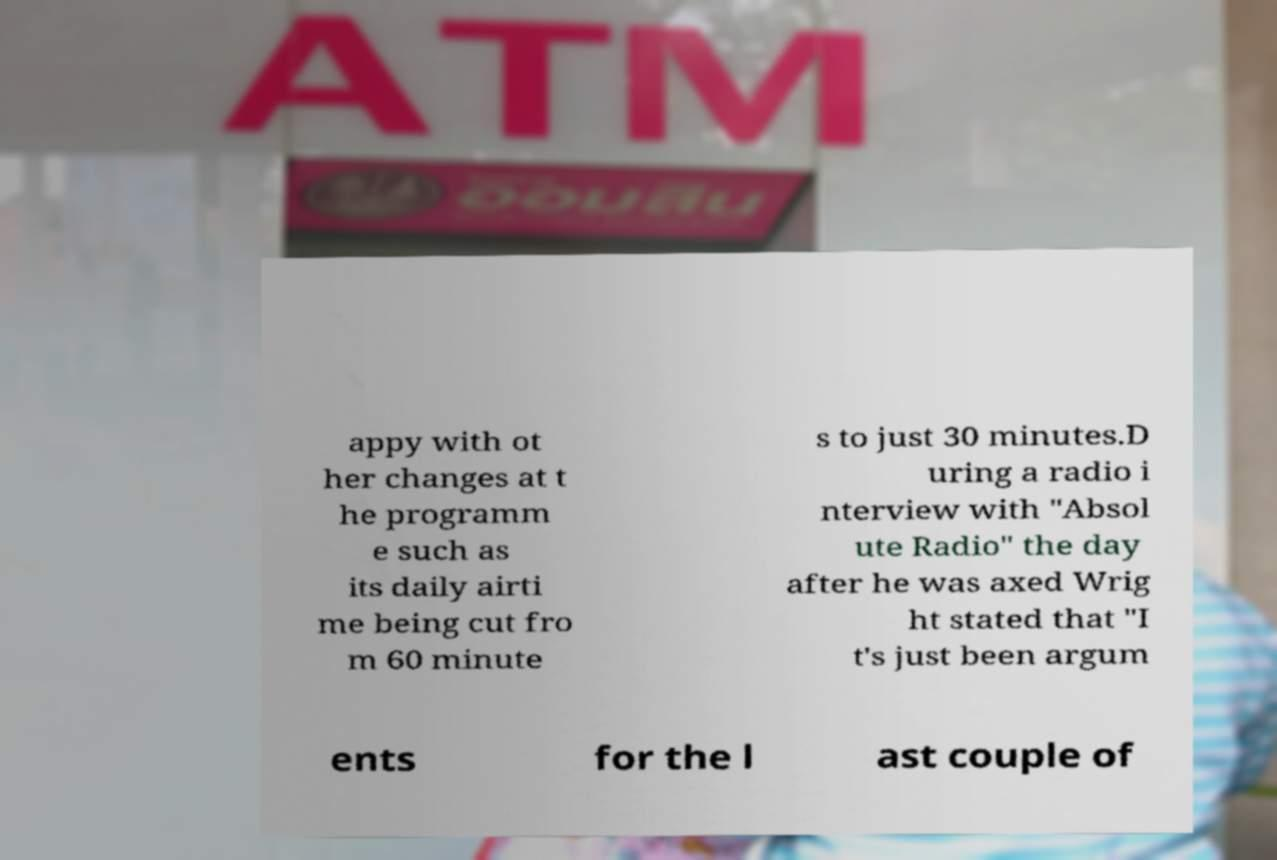There's text embedded in this image that I need extracted. Can you transcribe it verbatim? appy with ot her changes at t he programm e such as its daily airti me being cut fro m 60 minute s to just 30 minutes.D uring a radio i nterview with "Absol ute Radio" the day after he was axed Wrig ht stated that "I t's just been argum ents for the l ast couple of 